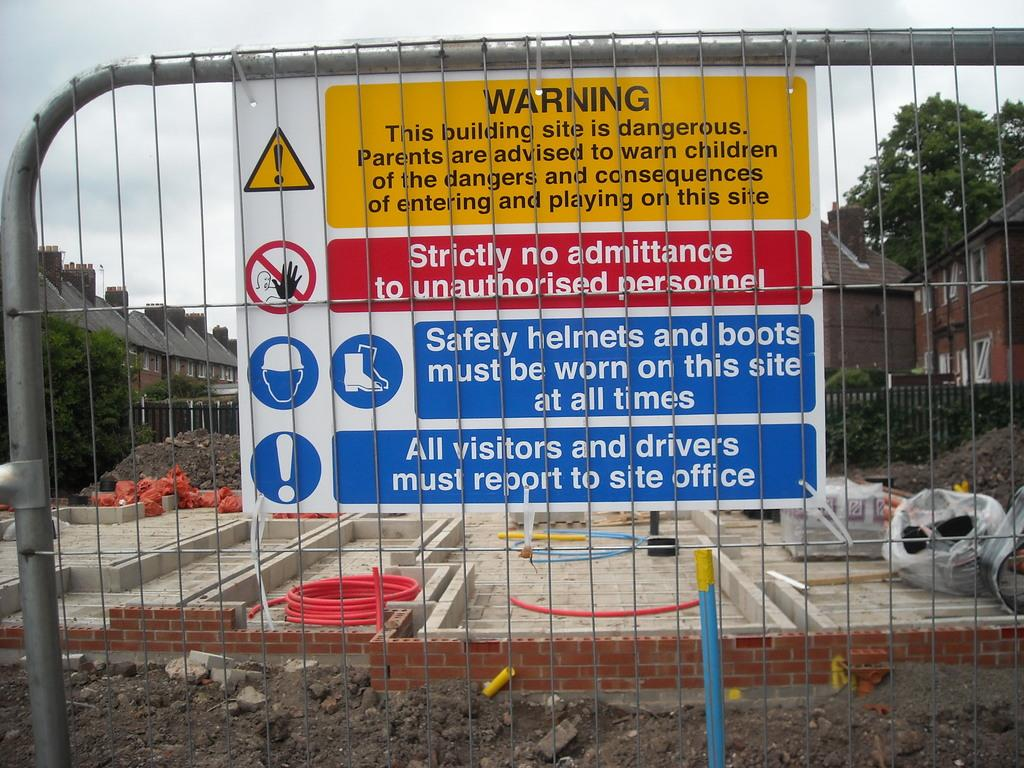<image>
Write a terse but informative summary of the picture. A yellow, red, and blue warning sign that says the building site behind it is dangerous. 